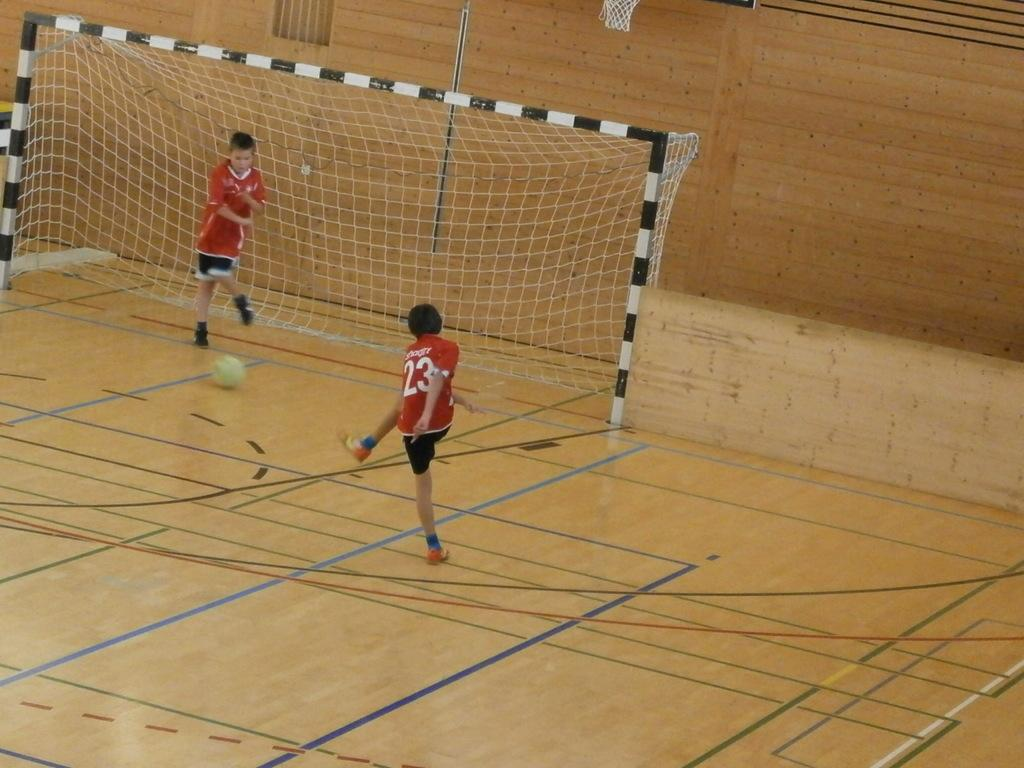<image>
Render a clear and concise summary of the photo. A boy wearing the number 23 kicks a ball at a net. 